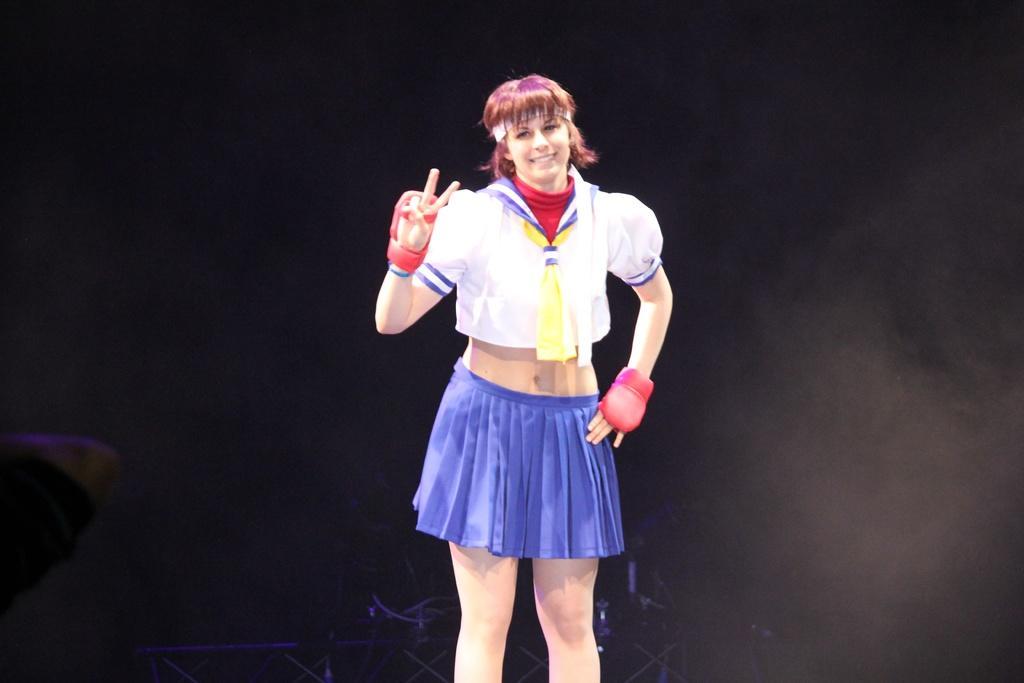Can you describe this image briefly? In this image in the center there is one person standing, and in the background there are some objects and there is a black background. On the right side there is one person's hand is visible. 